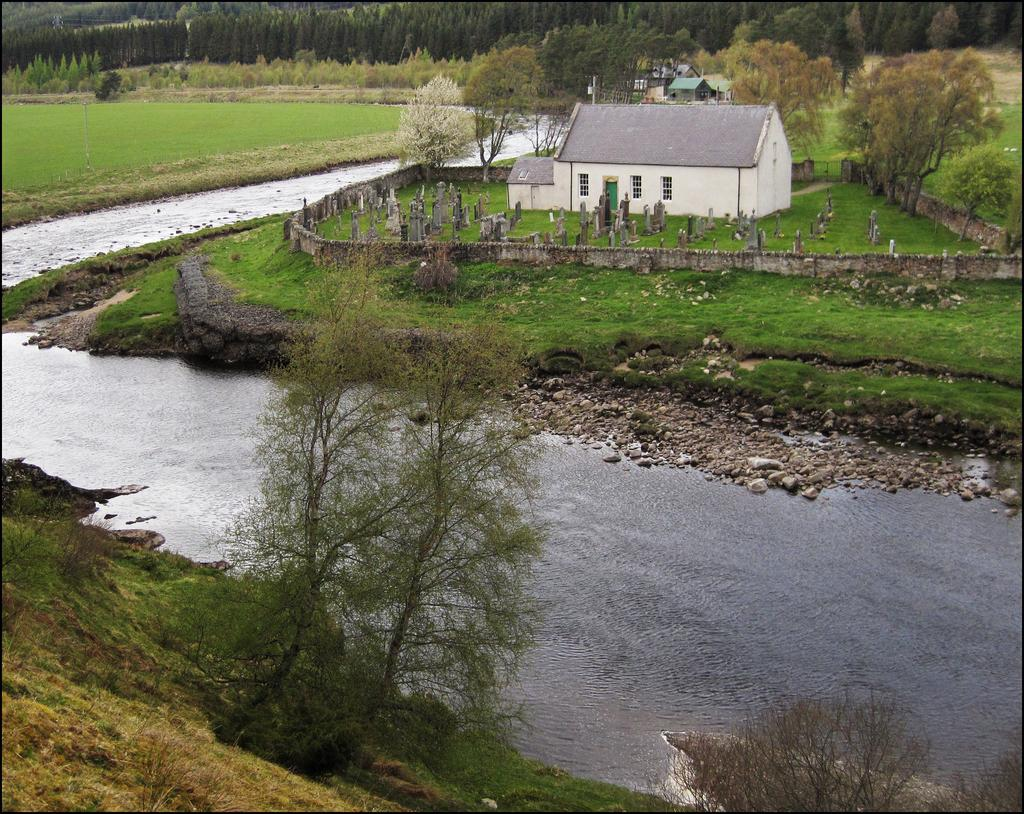What type of structure is visible in the image? There is a house in the image. What natural elements can be seen in the image? There are trees and a small lake in the image. What type of barrier is present in the image? There is a fence in the image. What flavor of ice cream is being traded between the trees in the image? There is no ice cream or trade activity present in the image. What relation do the trees have with the house in the image? The trees are separate entities from the house and do not have a direct relation with it in the image. 